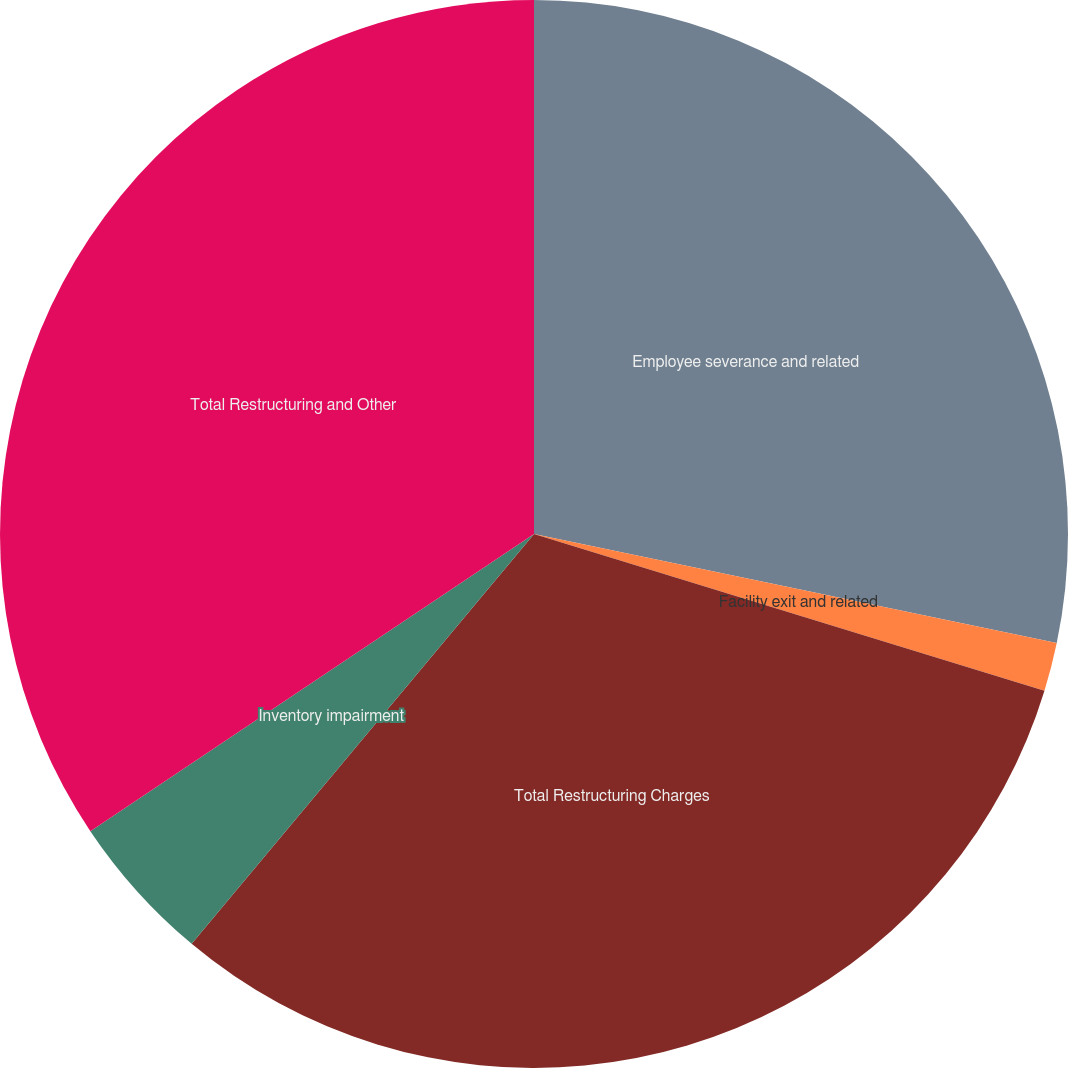<chart> <loc_0><loc_0><loc_500><loc_500><pie_chart><fcel>Employee severance and related<fcel>Facility exit and related<fcel>Total Restructuring Charges<fcel>Inventory impairment<fcel>Total Restructuring and Other<nl><fcel>28.27%<fcel>1.47%<fcel>31.33%<fcel>4.53%<fcel>34.39%<nl></chart> 